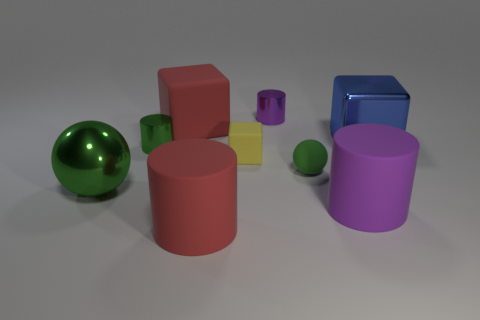Add 1 large green cubes. How many objects exist? 10 Subtract all blocks. How many objects are left? 6 Add 1 large red blocks. How many large red blocks are left? 2 Add 5 big blue shiny things. How many big blue shiny things exist? 6 Subtract 1 red cylinders. How many objects are left? 8 Subtract all small yellow objects. Subtract all blue metallic things. How many objects are left? 7 